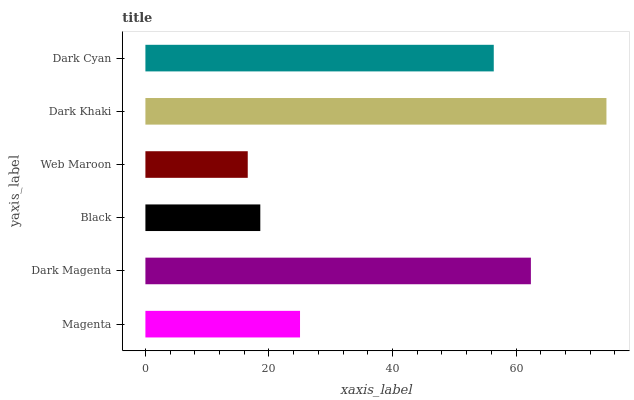Is Web Maroon the minimum?
Answer yes or no. Yes. Is Dark Khaki the maximum?
Answer yes or no. Yes. Is Dark Magenta the minimum?
Answer yes or no. No. Is Dark Magenta the maximum?
Answer yes or no. No. Is Dark Magenta greater than Magenta?
Answer yes or no. Yes. Is Magenta less than Dark Magenta?
Answer yes or no. Yes. Is Magenta greater than Dark Magenta?
Answer yes or no. No. Is Dark Magenta less than Magenta?
Answer yes or no. No. Is Dark Cyan the high median?
Answer yes or no. Yes. Is Magenta the low median?
Answer yes or no. Yes. Is Dark Khaki the high median?
Answer yes or no. No. Is Web Maroon the low median?
Answer yes or no. No. 